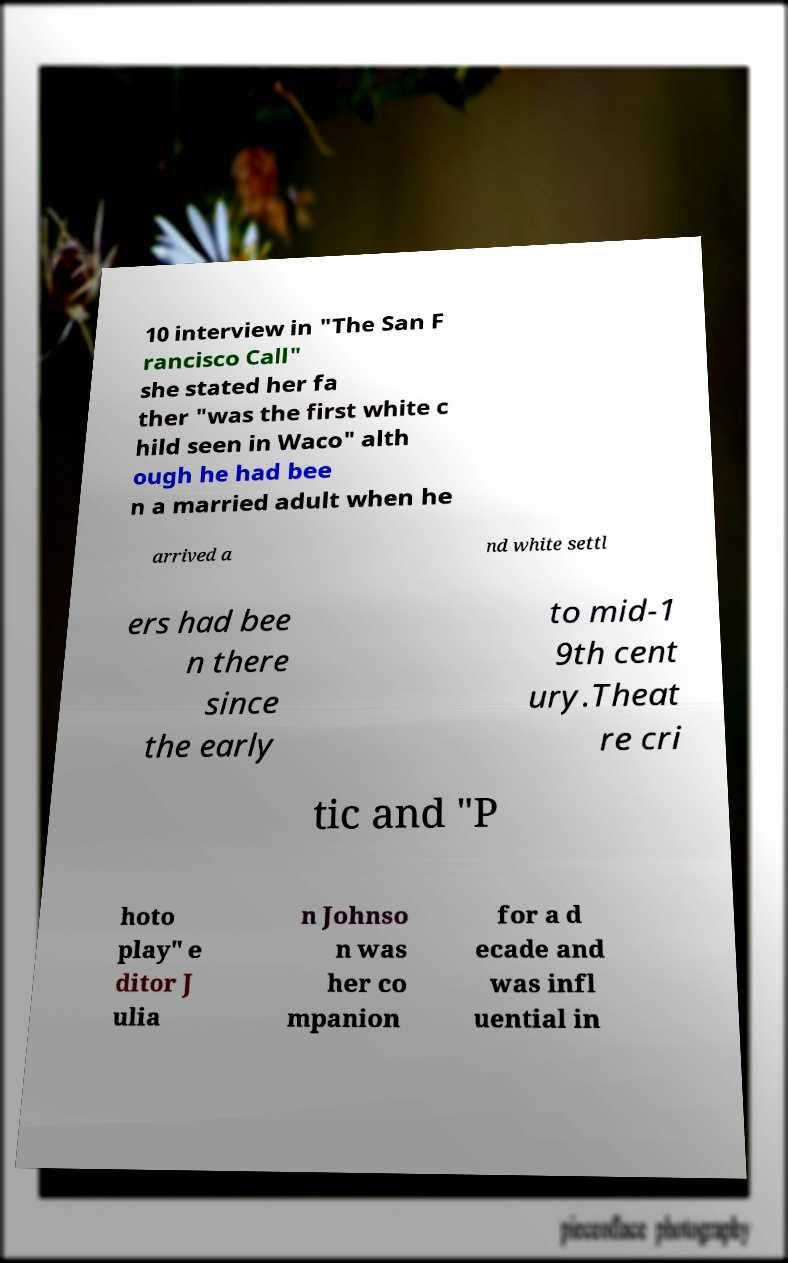There's text embedded in this image that I need extracted. Can you transcribe it verbatim? 10 interview in "The San F rancisco Call" she stated her fa ther "was the first white c hild seen in Waco" alth ough he had bee n a married adult when he arrived a nd white settl ers had bee n there since the early to mid-1 9th cent ury.Theat re cri tic and "P hoto play" e ditor J ulia n Johnso n was her co mpanion for a d ecade and was infl uential in 